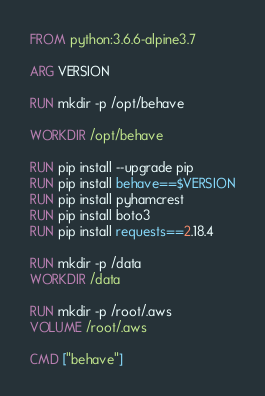Convert code to text. <code><loc_0><loc_0><loc_500><loc_500><_Dockerfile_>FROM python:3.6.6-alpine3.7

ARG VERSION

RUN mkdir -p /opt/behave

WORKDIR /opt/behave

RUN pip install --upgrade pip
RUN pip install behave==$VERSION
RUN pip install pyhamcrest
RUN pip install boto3
RUN pip install requests==2.18.4 

RUN mkdir -p /data
WORKDIR /data

RUN mkdir -p /root/.aws
VOLUME /root/.aws

CMD ["behave"]
</code> 